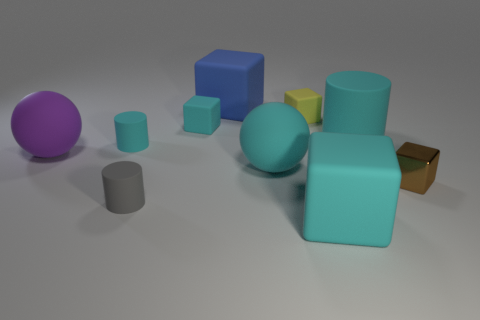Subtract 2 blocks. How many blocks are left? 3 Subtract all blue cubes. How many cubes are left? 4 Subtract all small brown cubes. How many cubes are left? 4 Subtract all red cubes. Subtract all blue cylinders. How many cubes are left? 5 Subtract all cylinders. How many objects are left? 7 Add 1 small cyan rubber blocks. How many small cyan rubber blocks exist? 2 Subtract 1 brown blocks. How many objects are left? 9 Subtract all big purple balls. Subtract all rubber cylinders. How many objects are left? 6 Add 2 small cyan matte cylinders. How many small cyan matte cylinders are left? 3 